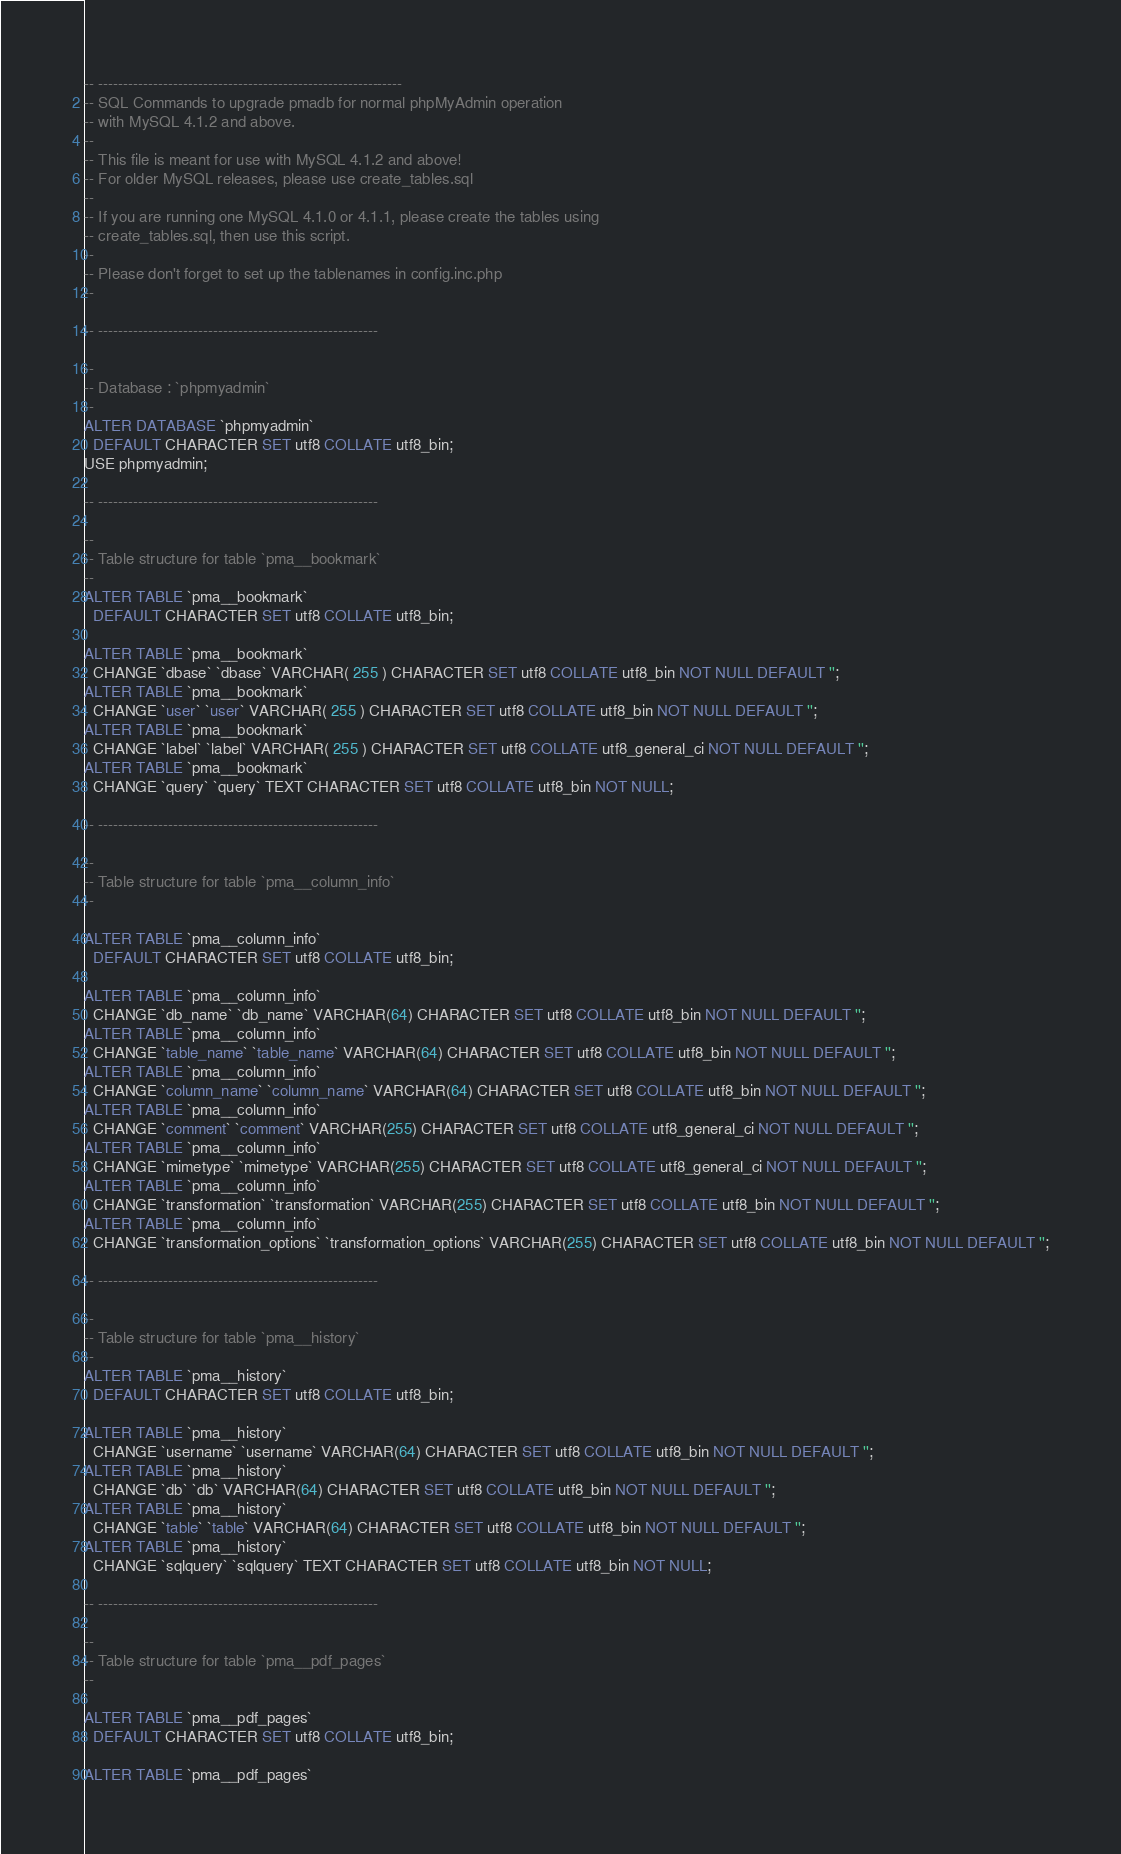Convert code to text. <code><loc_0><loc_0><loc_500><loc_500><_SQL_>-- -------------------------------------------------------------
-- SQL Commands to upgrade pmadb for normal phpMyAdmin operation
-- with MySQL 4.1.2 and above.
--
-- This file is meant for use with MySQL 4.1.2 and above!
-- For older MySQL releases, please use create_tables.sql
--
-- If you are running one MySQL 4.1.0 or 4.1.1, please create the tables using
-- create_tables.sql, then use this script.
--
-- Please don't forget to set up the tablenames in config.inc.php
--

-- --------------------------------------------------------

--
-- Database : `phpmyadmin`
--
ALTER DATABASE `phpmyadmin`
  DEFAULT CHARACTER SET utf8 COLLATE utf8_bin;
USE phpmyadmin;

-- --------------------------------------------------------

--
-- Table structure for table `pma__bookmark`
--
ALTER TABLE `pma__bookmark`
  DEFAULT CHARACTER SET utf8 COLLATE utf8_bin;

ALTER TABLE `pma__bookmark`
  CHANGE `dbase` `dbase` VARCHAR( 255 ) CHARACTER SET utf8 COLLATE utf8_bin NOT NULL DEFAULT '';
ALTER TABLE `pma__bookmark`
  CHANGE `user` `user` VARCHAR( 255 ) CHARACTER SET utf8 COLLATE utf8_bin NOT NULL DEFAULT '';
ALTER TABLE `pma__bookmark`
  CHANGE `label` `label` VARCHAR( 255 ) CHARACTER SET utf8 COLLATE utf8_general_ci NOT NULL DEFAULT '';
ALTER TABLE `pma__bookmark`
  CHANGE `query` `query` TEXT CHARACTER SET utf8 COLLATE utf8_bin NOT NULL;

-- --------------------------------------------------------

--
-- Table structure for table `pma__column_info`
--

ALTER TABLE `pma__column_info`
  DEFAULT CHARACTER SET utf8 COLLATE utf8_bin;

ALTER TABLE `pma__column_info`
  CHANGE `db_name` `db_name` VARCHAR(64) CHARACTER SET utf8 COLLATE utf8_bin NOT NULL DEFAULT '';
ALTER TABLE `pma__column_info`
  CHANGE `table_name` `table_name` VARCHAR(64) CHARACTER SET utf8 COLLATE utf8_bin NOT NULL DEFAULT '';
ALTER TABLE `pma__column_info`
  CHANGE `column_name` `column_name` VARCHAR(64) CHARACTER SET utf8 COLLATE utf8_bin NOT NULL DEFAULT '';
ALTER TABLE `pma__column_info`
  CHANGE `comment` `comment` VARCHAR(255) CHARACTER SET utf8 COLLATE utf8_general_ci NOT NULL DEFAULT '';
ALTER TABLE `pma__column_info`
  CHANGE `mimetype` `mimetype` VARCHAR(255) CHARACTER SET utf8 COLLATE utf8_general_ci NOT NULL DEFAULT '';
ALTER TABLE `pma__column_info`
  CHANGE `transformation` `transformation` VARCHAR(255) CHARACTER SET utf8 COLLATE utf8_bin NOT NULL DEFAULT '';
ALTER TABLE `pma__column_info`
  CHANGE `transformation_options` `transformation_options` VARCHAR(255) CHARACTER SET utf8 COLLATE utf8_bin NOT NULL DEFAULT '';

-- --------------------------------------------------------

--
-- Table structure for table `pma__history`
--
ALTER TABLE `pma__history`
  DEFAULT CHARACTER SET utf8 COLLATE utf8_bin;

ALTER TABLE `pma__history`
  CHANGE `username` `username` VARCHAR(64) CHARACTER SET utf8 COLLATE utf8_bin NOT NULL DEFAULT '';
ALTER TABLE `pma__history`
  CHANGE `db` `db` VARCHAR(64) CHARACTER SET utf8 COLLATE utf8_bin NOT NULL DEFAULT '';
ALTER TABLE `pma__history`
  CHANGE `table` `table` VARCHAR(64) CHARACTER SET utf8 COLLATE utf8_bin NOT NULL DEFAULT '';
ALTER TABLE `pma__history`
  CHANGE `sqlquery` `sqlquery` TEXT CHARACTER SET utf8 COLLATE utf8_bin NOT NULL;

-- --------------------------------------------------------

--
-- Table structure for table `pma__pdf_pages`
--

ALTER TABLE `pma__pdf_pages`
  DEFAULT CHARACTER SET utf8 COLLATE utf8_bin;

ALTER TABLE `pma__pdf_pages`</code> 